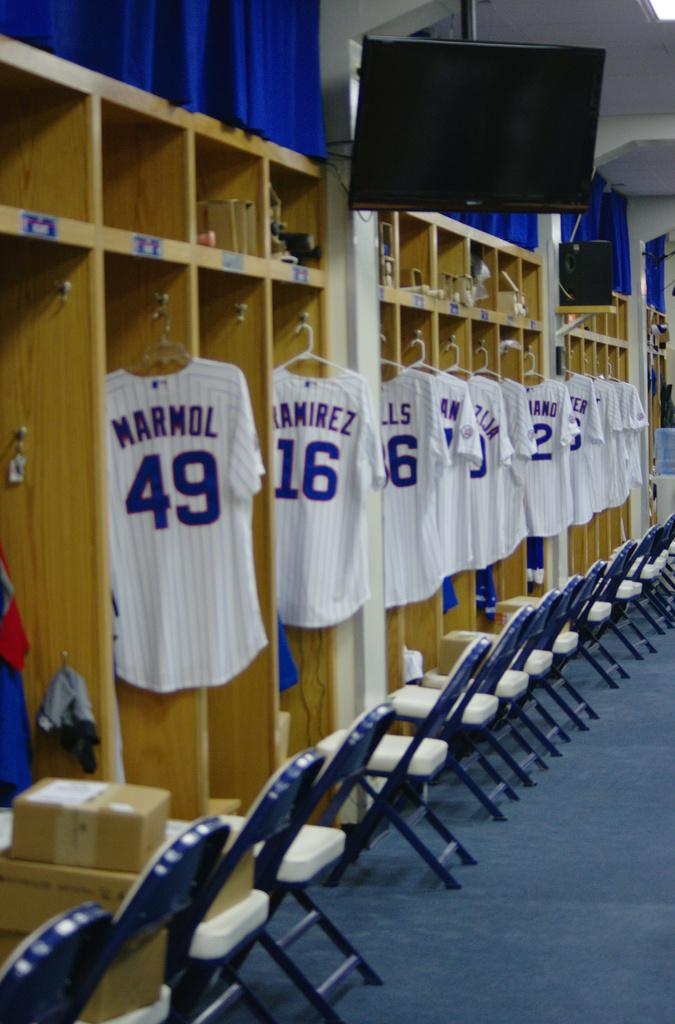<image>
Present a compact description of the photo's key features. Locker room shows jerseys hanging in a row starting with Marmol's on the left. 